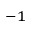Convert formula to latex. <formula><loc_0><loc_0><loc_500><loc_500>^ { - 1 }</formula> 